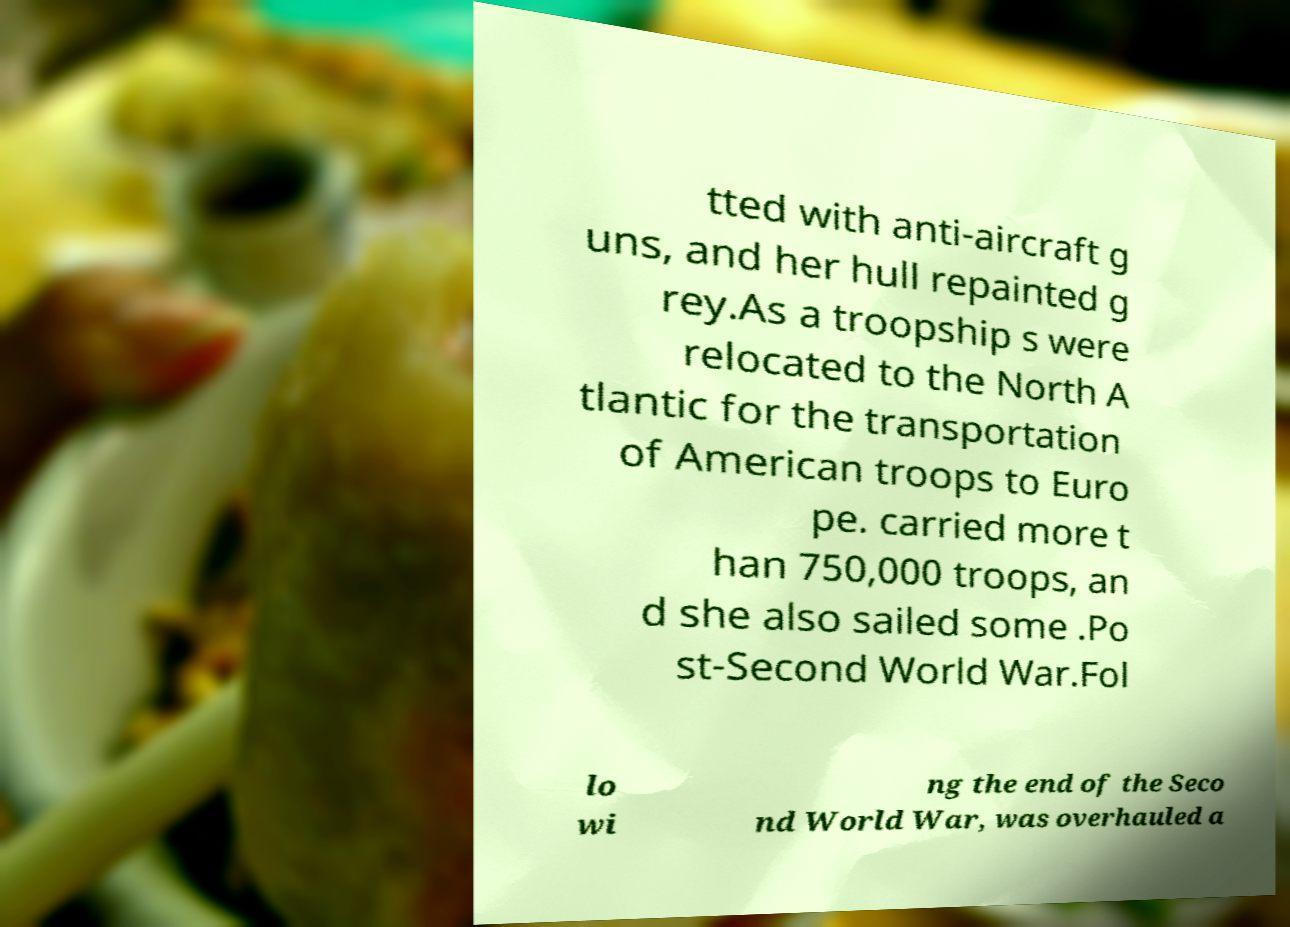Could you assist in decoding the text presented in this image and type it out clearly? tted with anti-aircraft g uns, and her hull repainted g rey.As a troopship s were relocated to the North A tlantic for the transportation of American troops to Euro pe. carried more t han 750,000 troops, an d she also sailed some .Po st-Second World War.Fol lo wi ng the end of the Seco nd World War, was overhauled a 